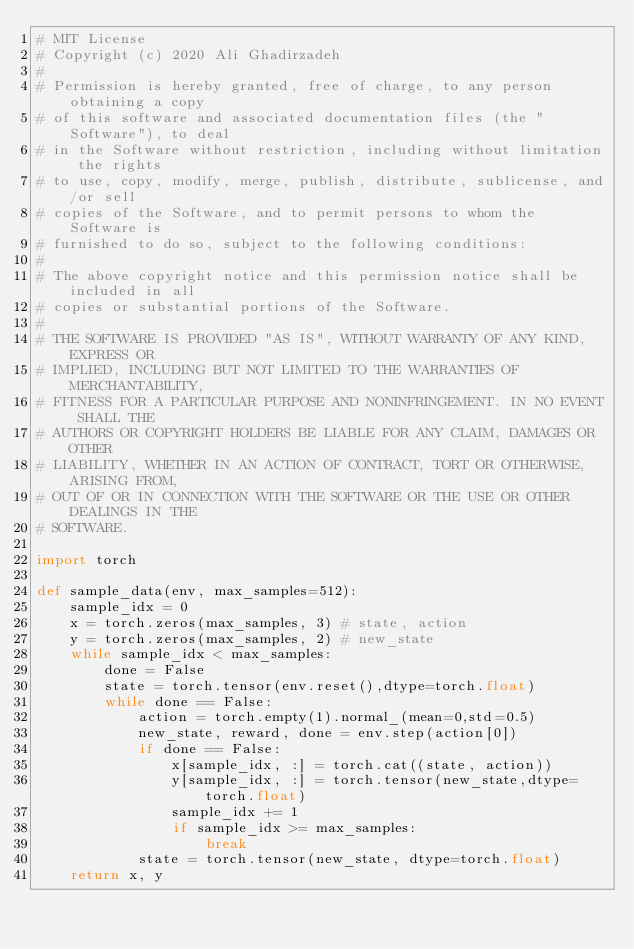<code> <loc_0><loc_0><loc_500><loc_500><_Python_># MIT License
# Copyright (c) 2020 Ali Ghadirzadeh
#
# Permission is hereby granted, free of charge, to any person obtaining a copy
# of this software and associated documentation files (the "Software"), to deal
# in the Software without restriction, including without limitation the rights
# to use, copy, modify, merge, publish, distribute, sublicense, and/or sell
# copies of the Software, and to permit persons to whom the Software is
# furnished to do so, subject to the following conditions:
#
# The above copyright notice and this permission notice shall be included in all
# copies or substantial portions of the Software.
#
# THE SOFTWARE IS PROVIDED "AS IS", WITHOUT WARRANTY OF ANY KIND, EXPRESS OR
# IMPLIED, INCLUDING BUT NOT LIMITED TO THE WARRANTIES OF MERCHANTABILITY,
# FITNESS FOR A PARTICULAR PURPOSE AND NONINFRINGEMENT. IN NO EVENT SHALL THE
# AUTHORS OR COPYRIGHT HOLDERS BE LIABLE FOR ANY CLAIM, DAMAGES OR OTHER
# LIABILITY, WHETHER IN AN ACTION OF CONTRACT, TORT OR OTHERWISE, ARISING FROM,
# OUT OF OR IN CONNECTION WITH THE SOFTWARE OR THE USE OR OTHER DEALINGS IN THE
# SOFTWARE.

import torch

def sample_data(env, max_samples=512):
    sample_idx = 0
    x = torch.zeros(max_samples, 3) # state, action
    y = torch.zeros(max_samples, 2) # new_state
    while sample_idx < max_samples:
        done = False
        state = torch.tensor(env.reset(),dtype=torch.float)
        while done == False:
            action = torch.empty(1).normal_(mean=0,std=0.5)
            new_state, reward, done = env.step(action[0])
            if done == False:
                x[sample_idx, :] = torch.cat((state, action))
                y[sample_idx, :] = torch.tensor(new_state,dtype=torch.float)
                sample_idx += 1
                if sample_idx >= max_samples:
                    break
            state = torch.tensor(new_state, dtype=torch.float)
    return x, y
</code> 